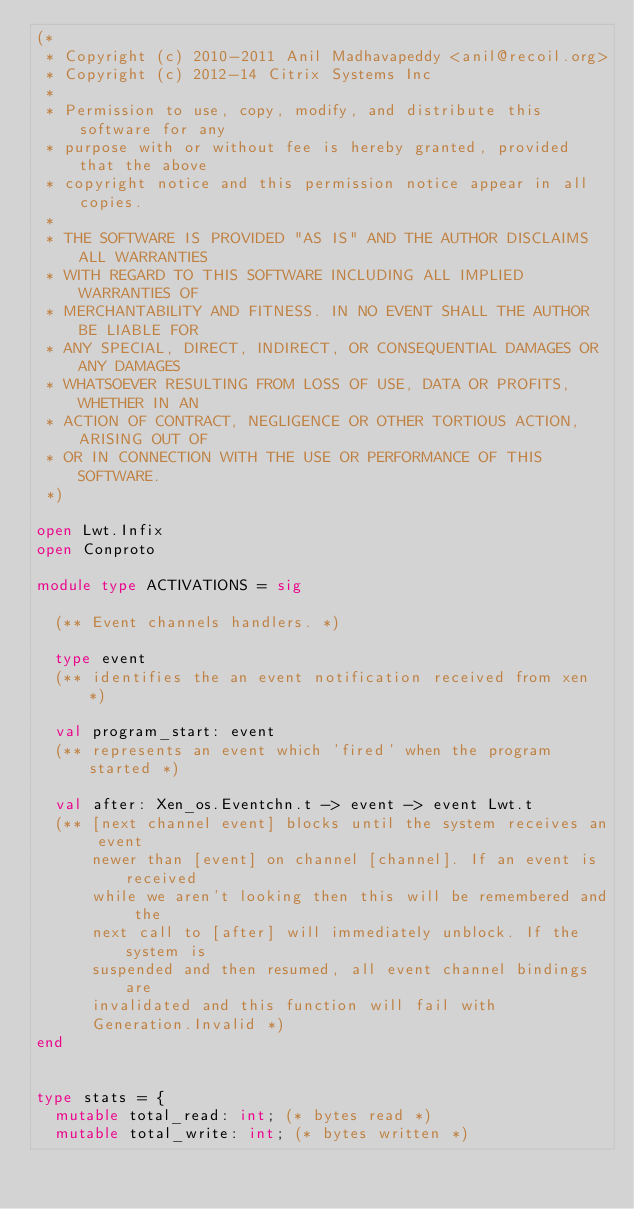<code> <loc_0><loc_0><loc_500><loc_500><_OCaml_>(*
 * Copyright (c) 2010-2011 Anil Madhavapeddy <anil@recoil.org>
 * Copyright (c) 2012-14 Citrix Systems Inc
 *
 * Permission to use, copy, modify, and distribute this software for any
 * purpose with or without fee is hereby granted, provided that the above
 * copyright notice and this permission notice appear in all copies.
 *
 * THE SOFTWARE IS PROVIDED "AS IS" AND THE AUTHOR DISCLAIMS ALL WARRANTIES
 * WITH REGARD TO THIS SOFTWARE INCLUDING ALL IMPLIED WARRANTIES OF
 * MERCHANTABILITY AND FITNESS. IN NO EVENT SHALL THE AUTHOR BE LIABLE FOR
 * ANY SPECIAL, DIRECT, INDIRECT, OR CONSEQUENTIAL DAMAGES OR ANY DAMAGES
 * WHATSOEVER RESULTING FROM LOSS OF USE, DATA OR PROFITS, WHETHER IN AN
 * ACTION OF CONTRACT, NEGLIGENCE OR OTHER TORTIOUS ACTION, ARISING OUT OF
 * OR IN CONNECTION WITH THE USE OR PERFORMANCE OF THIS SOFTWARE.
 *)

open Lwt.Infix
open Conproto

module type ACTIVATIONS = sig

  (** Event channels handlers. *)

  type event
  (** identifies the an event notification received from xen *)

  val program_start: event
  (** represents an event which 'fired' when the program started *)

  val after: Xen_os.Eventchn.t -> event -> event Lwt.t
  (** [next channel event] blocks until the system receives an event
      newer than [event] on channel [channel]. If an event is received
      while we aren't looking then this will be remembered and the
      next call to [after] will immediately unblock. If the system is
      suspended and then resumed, all event channel bindings are
      invalidated and this function will fail with
      Generation.Invalid *)
end


type stats = {
  mutable total_read: int; (* bytes read *)
  mutable total_write: int; (* bytes written *)</code> 